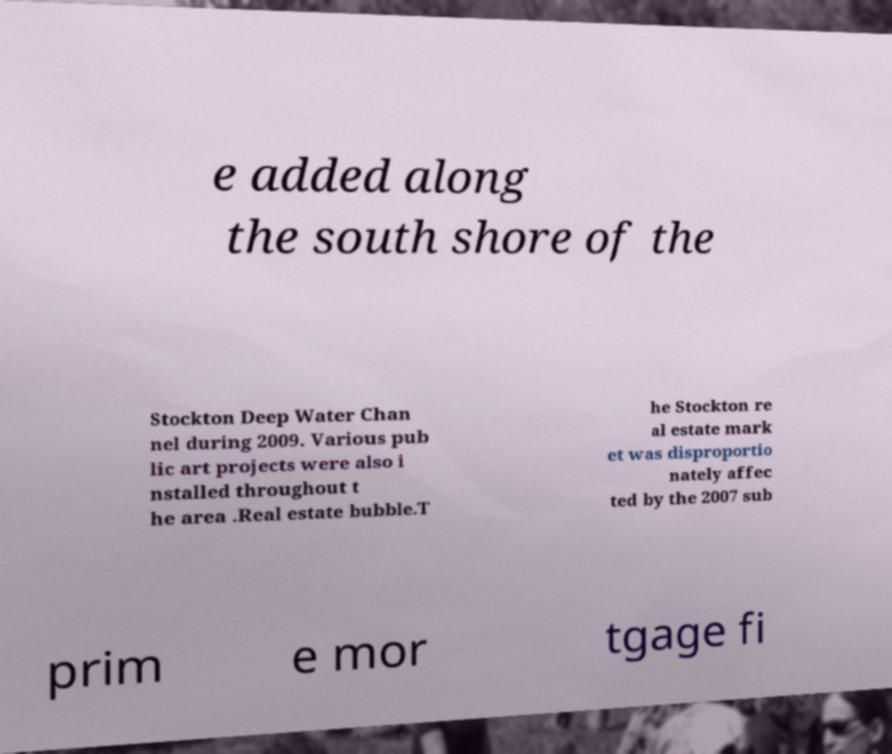Could you assist in decoding the text presented in this image and type it out clearly? e added along the south shore of the Stockton Deep Water Chan nel during 2009. Various pub lic art projects were also i nstalled throughout t he area .Real estate bubble.T he Stockton re al estate mark et was disproportio nately affec ted by the 2007 sub prim e mor tgage fi 